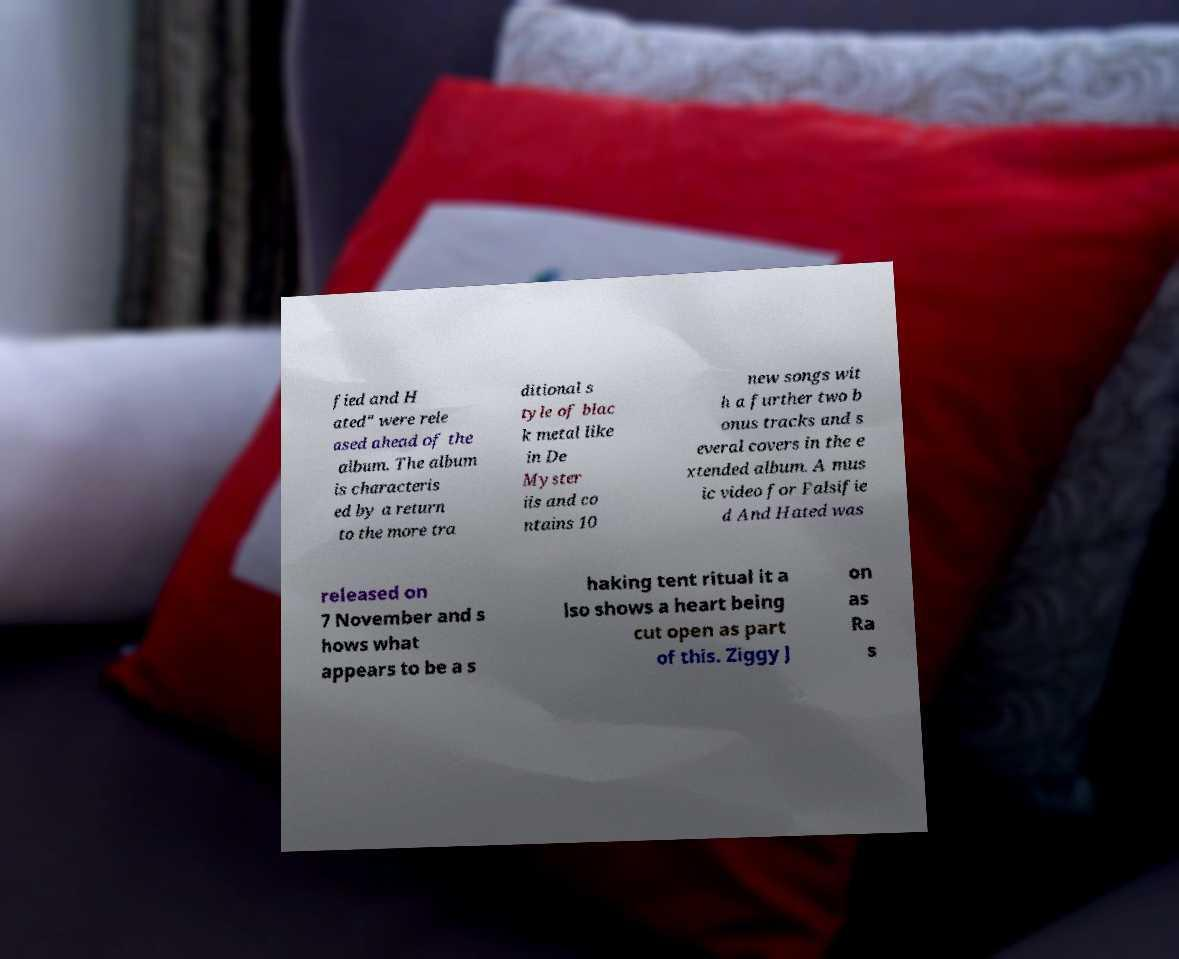I need the written content from this picture converted into text. Can you do that? fied and H ated" were rele ased ahead of the album. The album is characteris ed by a return to the more tra ditional s tyle of blac k metal like in De Myster iis and co ntains 10 new songs wit h a further two b onus tracks and s everal covers in the e xtended album. A mus ic video for Falsifie d And Hated was released on 7 November and s hows what appears to be a s haking tent ritual it a lso shows a heart being cut open as part of this. Ziggy J on as Ra s 